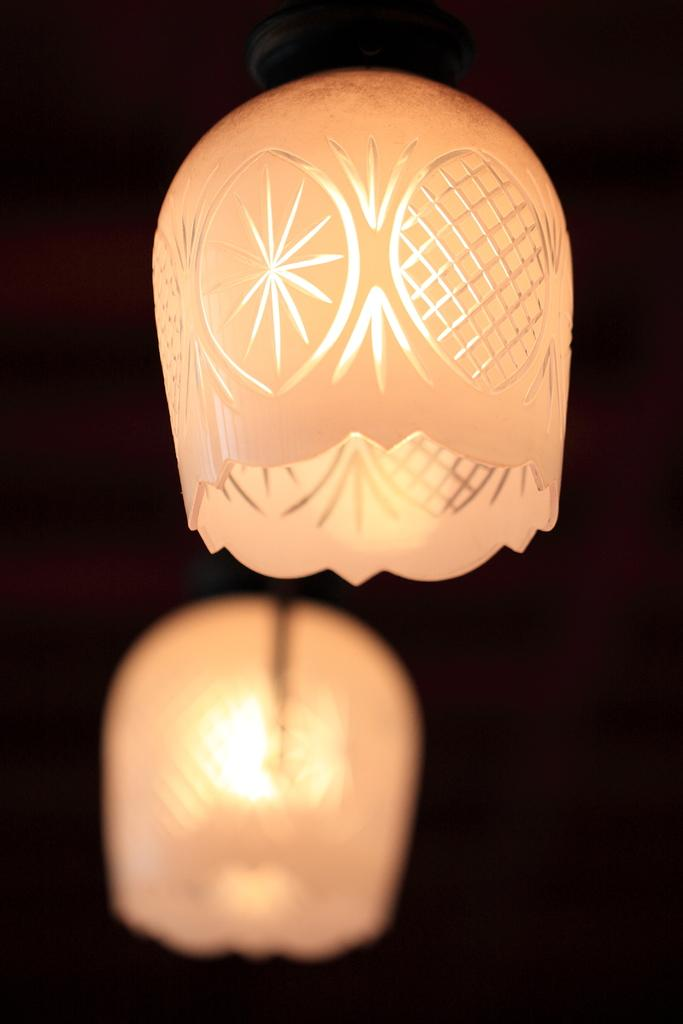What can be seen in the image that emits light? There are lights in the image. What color is visible in the image? The color black is present in the image. How much debt is represented by the black color in the image? There is no indication of debt in the image, and the black color is not associated with any financial representation. 